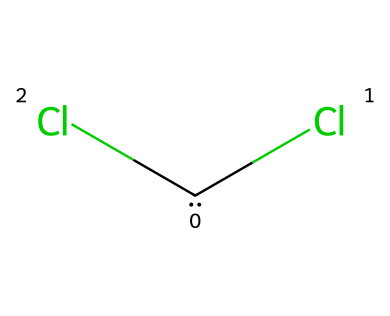What is the molecular formula of dichlorocarbene? The SMILES representation [C](Cl)Cl indicates one carbon atom (C) and two chlorine atoms (Cl) attached to it, leading to the molecular formula CCl2.
Answer: CCl2 How many total atoms are present in dichlorocarbene? The chemical structure shows one carbon atom and two chlorine atoms, which sums up to three total atoms.
Answer: 3 What type of hybridization is exhibited by the carbon in dichlorocarbene? The carbon atom in dichlorocarbene forms two single bonds with chlorine and has a lone pair, which places it in an sp2 hybridization state.
Answer: sp2 What is the geometry around the carbon atom in dichlorocarbene? Considering the sp2 hybridization and the presence of one lone pair, the geometry around the carbon atom is trigonal planar.
Answer: trigonal planar Is dichlorocarbene a stable compound or a reactive intermediate? Due to its structural characteristics, including the presence of a lone pair on the carbon and its strong tendency to react with other molecules, dichlorocarbene is classified as a reactive intermediate.
Answer: reactive intermediate What type of compound is dichlorocarbene categorized under? Carbenes, such as dichlorocarbene, are classified as reactive species with divalent carbon species that have two unshared valences.
Answer: carbene 